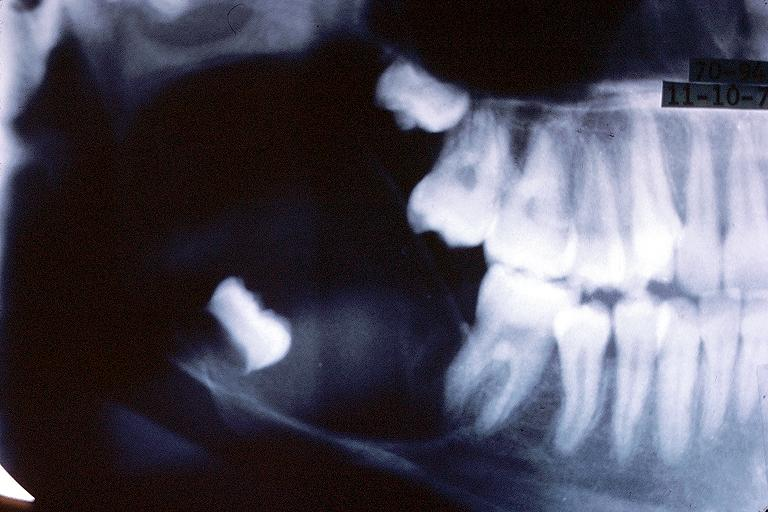s bone, calvarium present?
Answer the question using a single word or phrase. No 